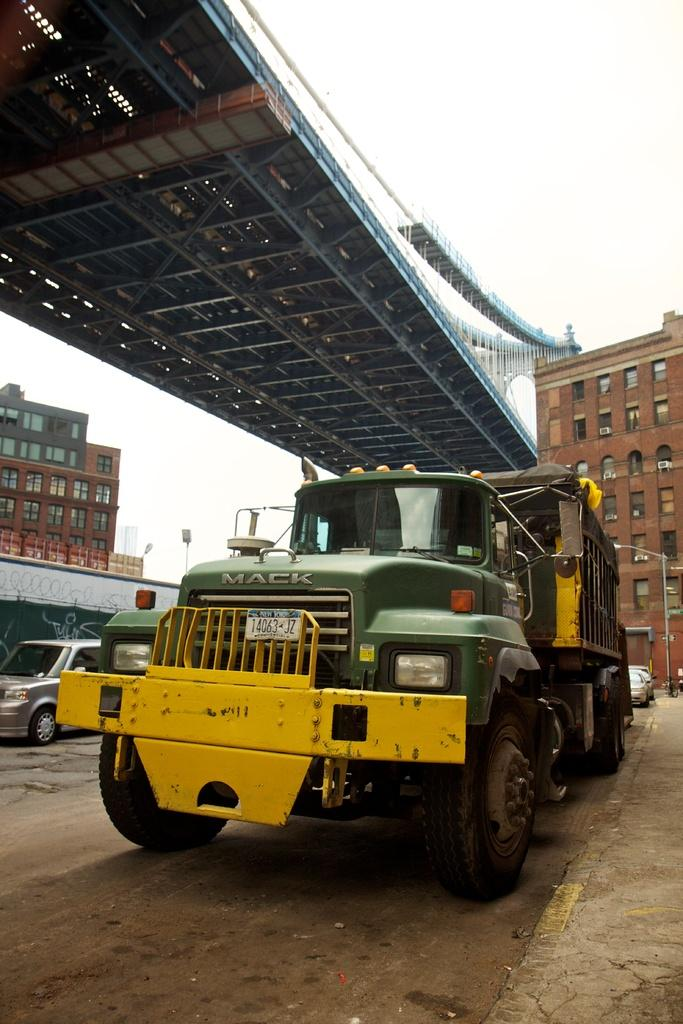<image>
Relay a brief, clear account of the picture shown. A green and yellow truck with the name brand Mack and NY tags. 